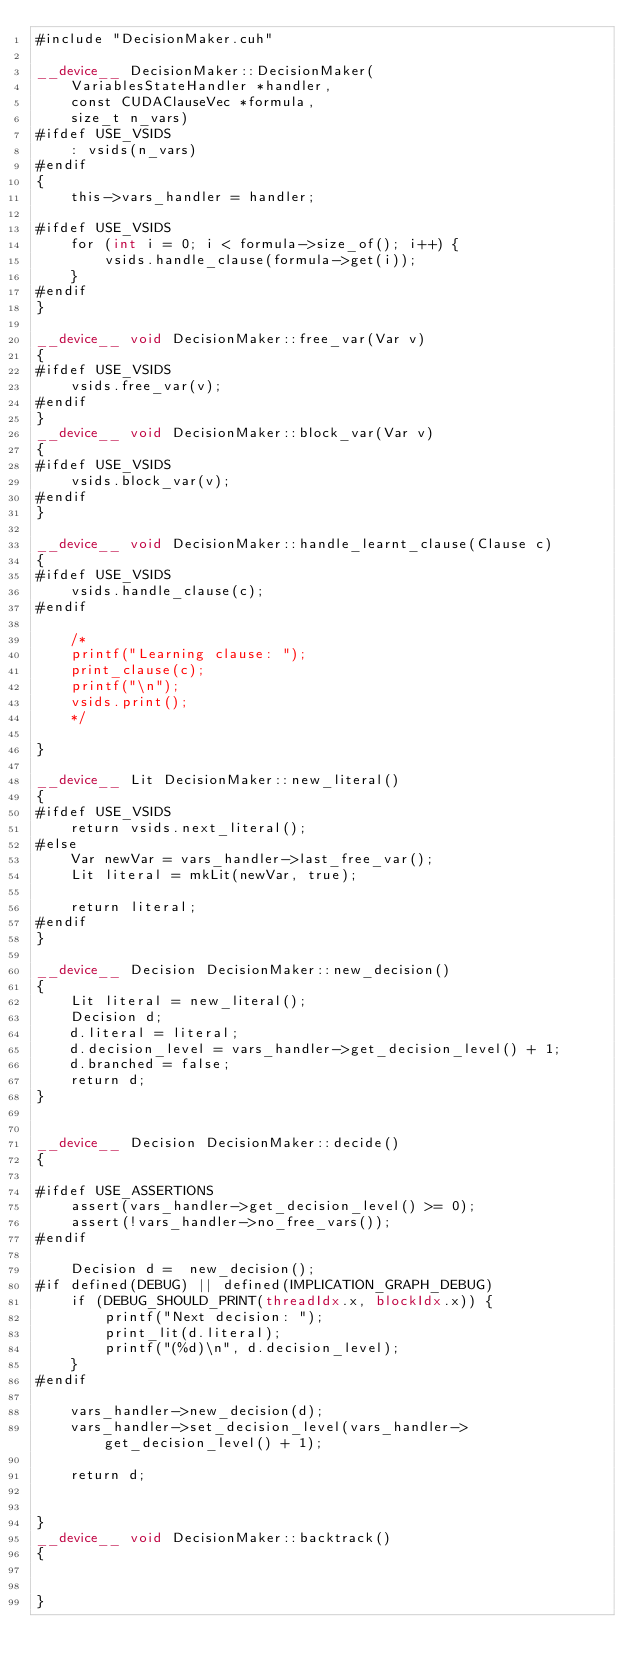Convert code to text. <code><loc_0><loc_0><loc_500><loc_500><_Cuda_>#include "DecisionMaker.cuh"

__device__ DecisionMaker::DecisionMaker(
    VariablesStateHandler *handler,
    const CUDAClauseVec *formula,
    size_t n_vars)
#ifdef USE_VSIDS
    : vsids(n_vars)
#endif
{
    this->vars_handler = handler;

#ifdef USE_VSIDS
    for (int i = 0; i < formula->size_of(); i++) {
        vsids.handle_clause(formula->get(i));
    }
#endif
}

__device__ void DecisionMaker::free_var(Var v)
{
#ifdef USE_VSIDS
    vsids.free_var(v);
#endif
}
__device__ void DecisionMaker::block_var(Var v)
{
#ifdef USE_VSIDS
    vsids.block_var(v);
#endif
}

__device__ void DecisionMaker::handle_learnt_clause(Clause c)
{
#ifdef USE_VSIDS
    vsids.handle_clause(c);
#endif

    /*
    printf("Learning clause: ");
    print_clause(c);
    printf("\n");
    vsids.print();
    */

}

__device__ Lit DecisionMaker::new_literal()
{
#ifdef USE_VSIDS
    return vsids.next_literal();
#else
    Var newVar = vars_handler->last_free_var();
    Lit literal = mkLit(newVar, true);

    return literal;
#endif
}

__device__ Decision DecisionMaker::new_decision()
{
    Lit literal = new_literal();
    Decision d;
    d.literal = literal;
    d.decision_level = vars_handler->get_decision_level() + 1;
    d.branched = false;
    return d;
}


__device__ Decision DecisionMaker::decide()
{

#ifdef USE_ASSERTIONS
    assert(vars_handler->get_decision_level() >= 0);
    assert(!vars_handler->no_free_vars());
#endif

    Decision d =  new_decision();
#if defined(DEBUG) || defined(IMPLICATION_GRAPH_DEBUG)
    if (DEBUG_SHOULD_PRINT(threadIdx.x, blockIdx.x)) {
        printf("Next decision: ");
        print_lit(d.literal);
        printf("(%d)\n", d.decision_level);
    }
#endif

    vars_handler->new_decision(d);
    vars_handler->set_decision_level(vars_handler->get_decision_level() + 1);

    return d;


}
__device__ void DecisionMaker::backtrack()
{


}
</code> 